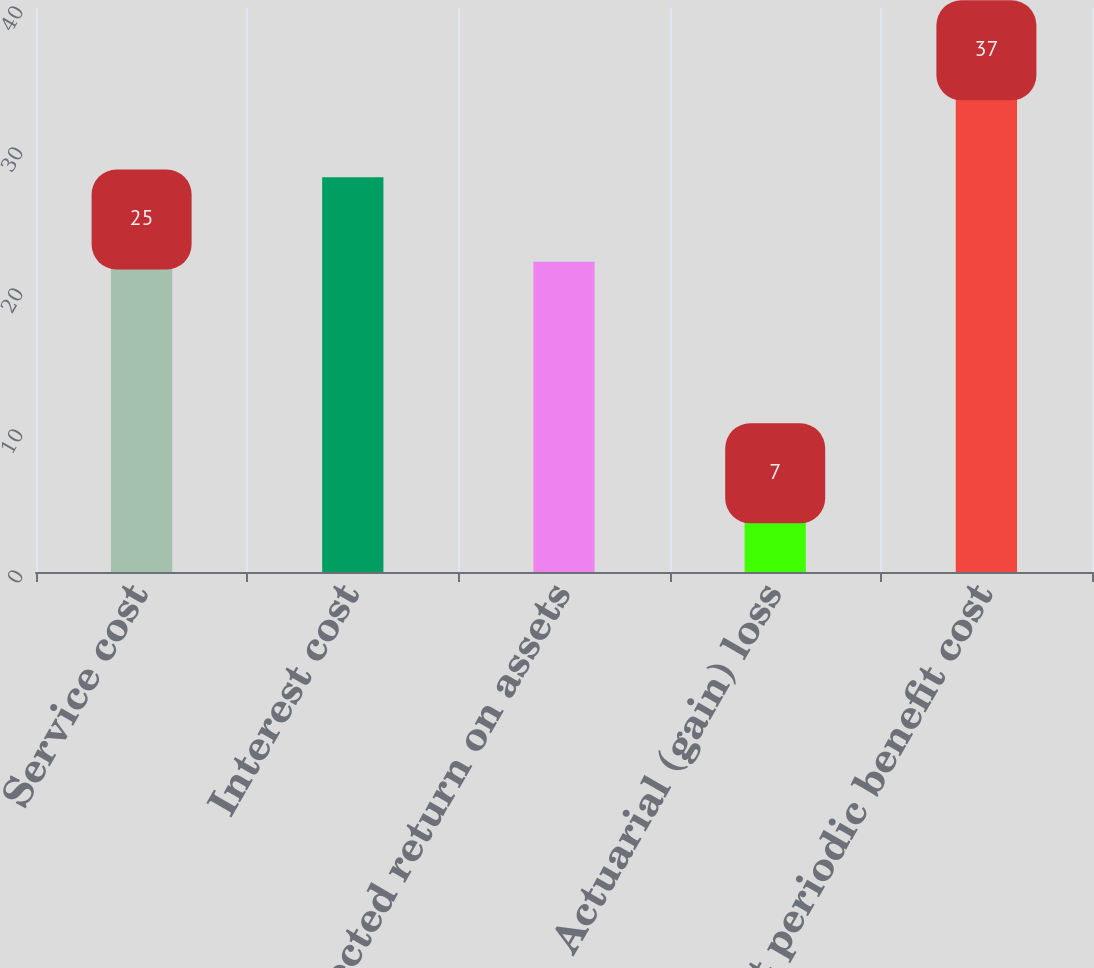<chart> <loc_0><loc_0><loc_500><loc_500><bar_chart><fcel>Service cost<fcel>Interest cost<fcel>Expected return on assets<fcel>Actuarial (gain) loss<fcel>Net periodic benefit cost<nl><fcel>25<fcel>28<fcel>22<fcel>7<fcel>37<nl></chart> 